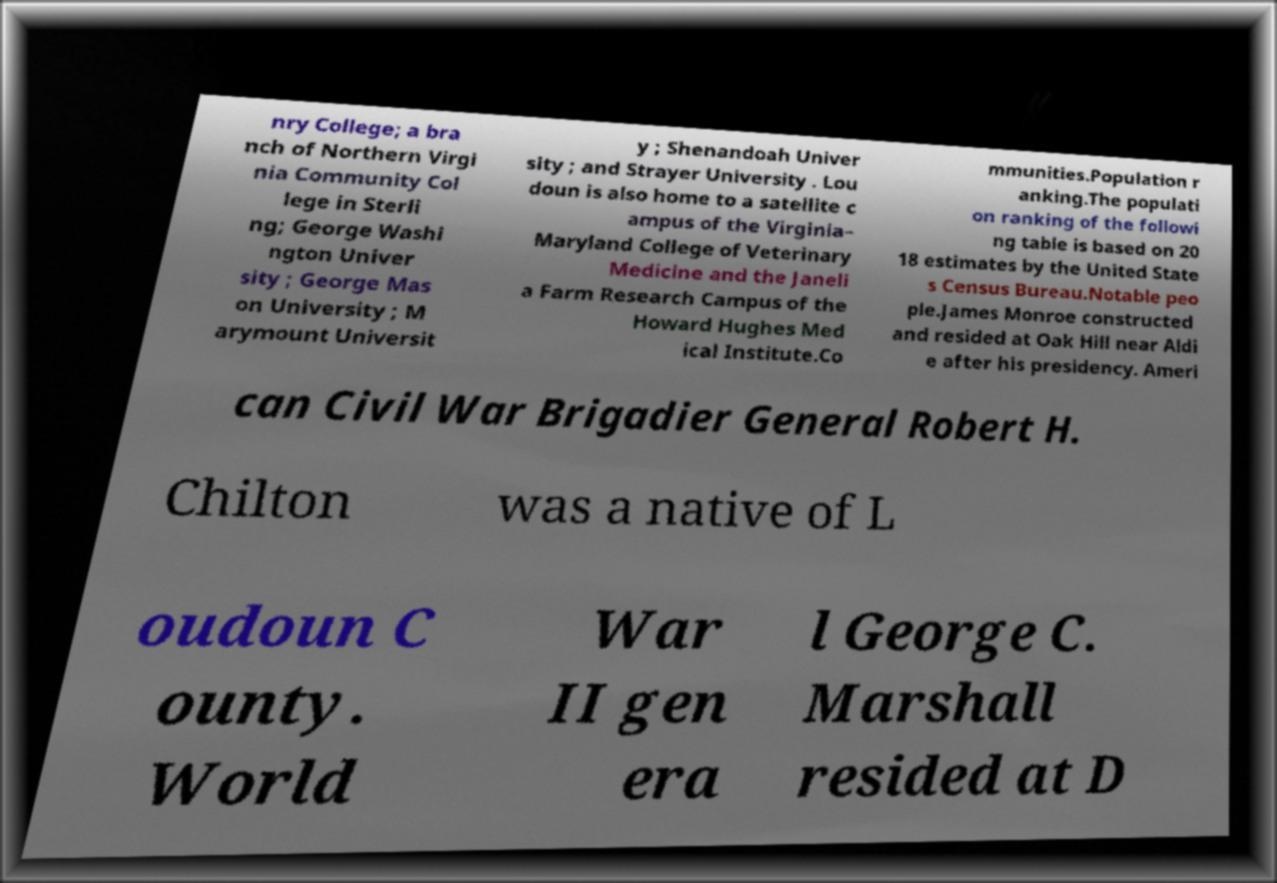Please read and relay the text visible in this image. What does it say? nry College; a bra nch of Northern Virgi nia Community Col lege in Sterli ng; George Washi ngton Univer sity ; George Mas on University ; M arymount Universit y ; Shenandoah Univer sity ; and Strayer University . Lou doun is also home to a satellite c ampus of the Virginia– Maryland College of Veterinary Medicine and the Janeli a Farm Research Campus of the Howard Hughes Med ical Institute.Co mmunities.Population r anking.The populati on ranking of the followi ng table is based on 20 18 estimates by the United State s Census Bureau.Notable peo ple.James Monroe constructed and resided at Oak Hill near Aldi e after his presidency. Ameri can Civil War Brigadier General Robert H. Chilton was a native of L oudoun C ounty. World War II gen era l George C. Marshall resided at D 